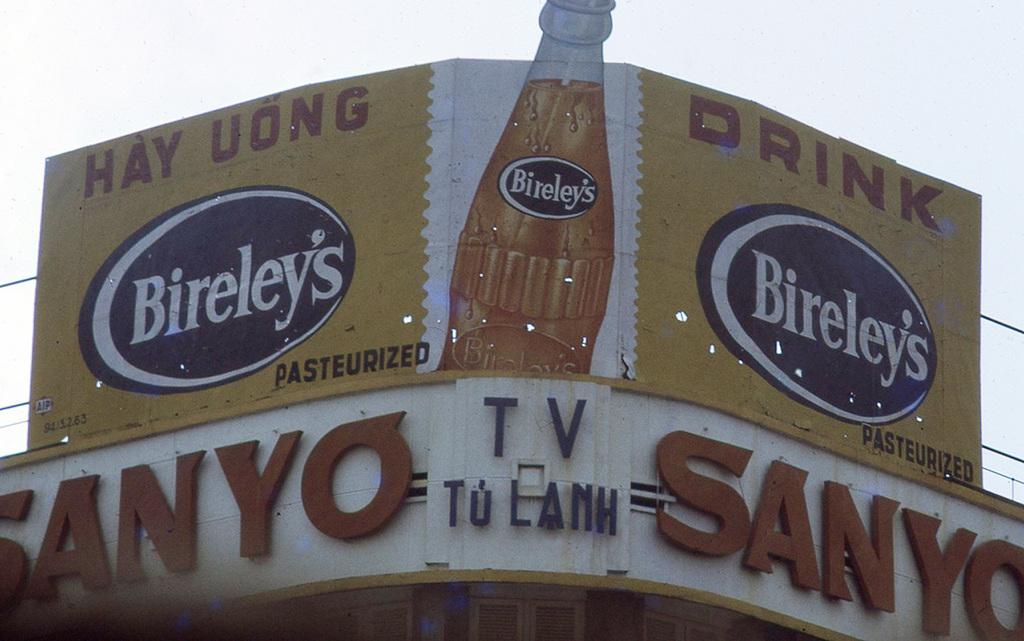Provide a one-sentence caption for the provided image. A sign above a Sanyo TV store that says "Drink Bireley's Pasteurized". 